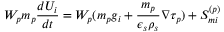<formula> <loc_0><loc_0><loc_500><loc_500>W _ { p } m _ { p } \frac { d U _ { i } } { d t } = W _ { p } ( m _ { p } g _ { i } + \frac { m _ { p } } { \epsilon _ { s } \rho _ { s } } \nabla \tau _ { p } ) + S _ { m i } ^ { ( p ) }</formula> 